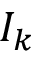<formula> <loc_0><loc_0><loc_500><loc_500>I _ { k }</formula> 